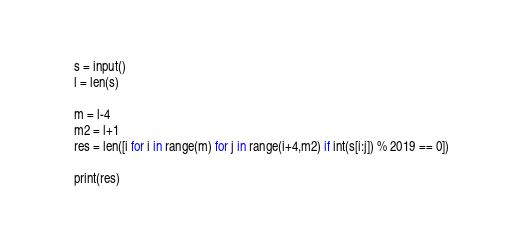Convert code to text. <code><loc_0><loc_0><loc_500><loc_500><_Python_>s = input()
l = len(s)

m = l-4
m2 = l+1
res = len([i for i in range(m) for j in range(i+4,m2) if int(s[i:j]) % 2019 == 0])

print(res)
</code> 